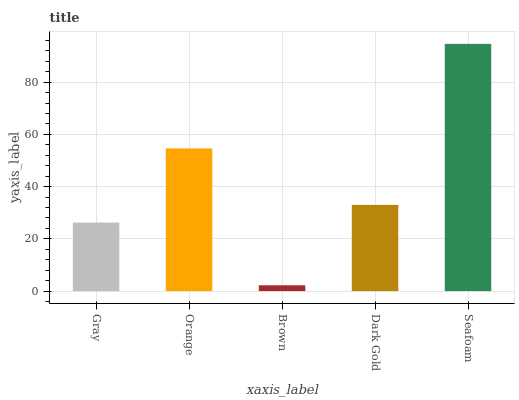Is Brown the minimum?
Answer yes or no. Yes. Is Seafoam the maximum?
Answer yes or no. Yes. Is Orange the minimum?
Answer yes or no. No. Is Orange the maximum?
Answer yes or no. No. Is Orange greater than Gray?
Answer yes or no. Yes. Is Gray less than Orange?
Answer yes or no. Yes. Is Gray greater than Orange?
Answer yes or no. No. Is Orange less than Gray?
Answer yes or no. No. Is Dark Gold the high median?
Answer yes or no. Yes. Is Dark Gold the low median?
Answer yes or no. Yes. Is Gray the high median?
Answer yes or no. No. Is Seafoam the low median?
Answer yes or no. No. 